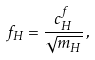Convert formula to latex. <formula><loc_0><loc_0><loc_500><loc_500>f _ { H } = \frac { c _ { H } ^ { f } } { \sqrt { m _ { H } } } \, ,</formula> 